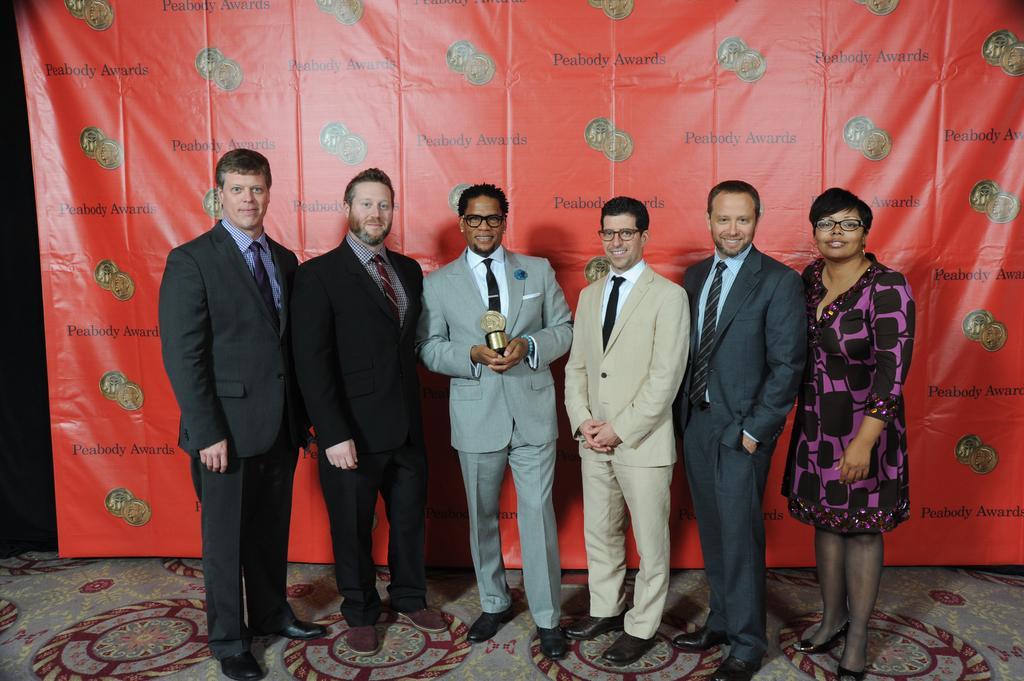Can you describe this image briefly? In this picture we can see six persons are standing and smiling, a man in the middle is holding a trophy, in the background we can see a banner. 